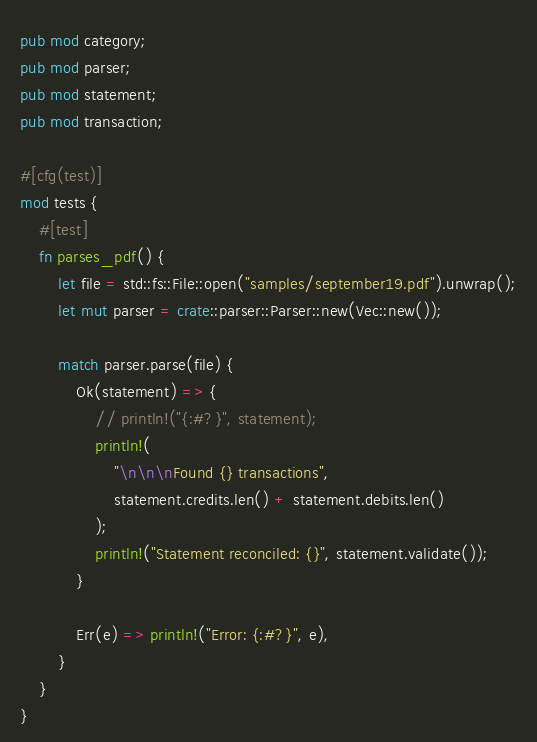<code> <loc_0><loc_0><loc_500><loc_500><_Rust_>pub mod category;
pub mod parser;
pub mod statement;
pub mod transaction;

#[cfg(test)]
mod tests {
    #[test]
    fn parses_pdf() {
        let file = std::fs::File::open("samples/september19.pdf").unwrap();
        let mut parser = crate::parser::Parser::new(Vec::new());

        match parser.parse(file) {
            Ok(statement) => {
                // println!("{:#?}", statement);
                println!(
                    "\n\n\nFound {} transactions",
                    statement.credits.len() + statement.debits.len()
                );
                println!("Statement reconciled: {}", statement.validate());
            }

            Err(e) => println!("Error: {:#?}", e),
        }
    }
}
</code> 